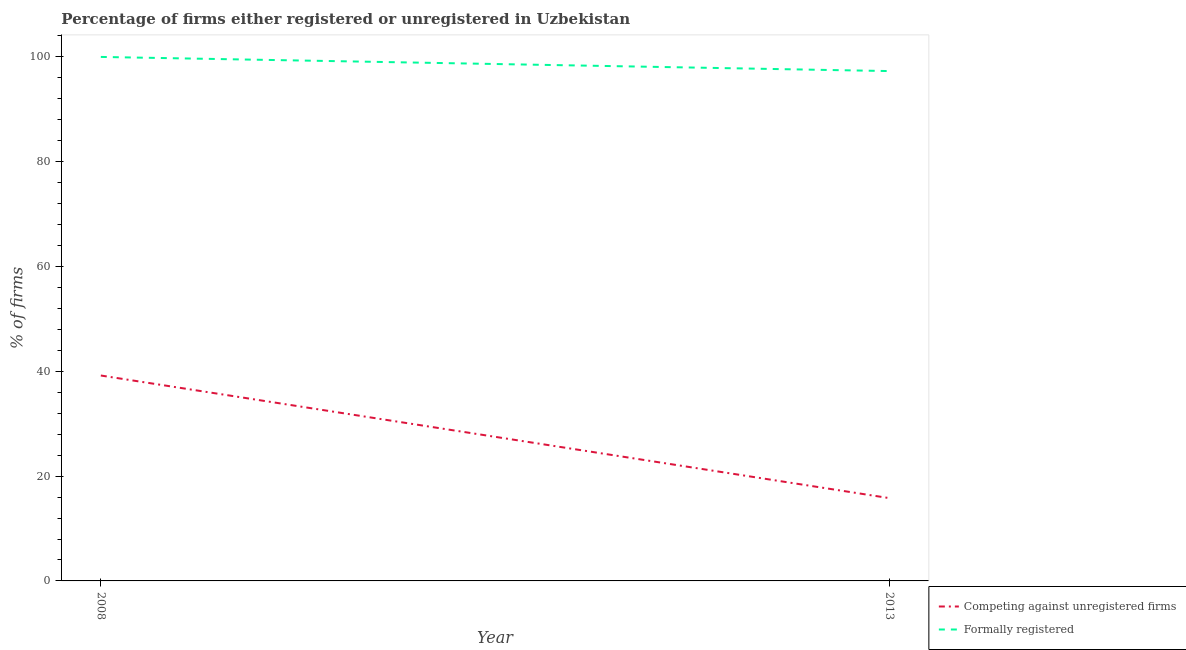How many different coloured lines are there?
Keep it short and to the point. 2. Across all years, what is the maximum percentage of formally registered firms?
Your answer should be compact. 100. Across all years, what is the minimum percentage of registered firms?
Offer a terse response. 15.8. In which year was the percentage of registered firms maximum?
Provide a short and direct response. 2008. In which year was the percentage of formally registered firms minimum?
Offer a very short reply. 2013. What is the total percentage of formally registered firms in the graph?
Your answer should be very brief. 197.3. What is the difference between the percentage of registered firms in 2008 and that in 2013?
Provide a short and direct response. 23.4. What is the difference between the percentage of registered firms in 2013 and the percentage of formally registered firms in 2008?
Keep it short and to the point. -84.2. In the year 2008, what is the difference between the percentage of registered firms and percentage of formally registered firms?
Your answer should be compact. -60.8. What is the ratio of the percentage of registered firms in 2008 to that in 2013?
Your answer should be very brief. 2.48. Is the percentage of registered firms in 2008 less than that in 2013?
Give a very brief answer. No. Is the percentage of formally registered firms strictly greater than the percentage of registered firms over the years?
Your answer should be very brief. Yes. Is the percentage of formally registered firms strictly less than the percentage of registered firms over the years?
Provide a short and direct response. No. How many lines are there?
Your answer should be compact. 2. What is the difference between two consecutive major ticks on the Y-axis?
Ensure brevity in your answer.  20. Are the values on the major ticks of Y-axis written in scientific E-notation?
Offer a very short reply. No. Where does the legend appear in the graph?
Ensure brevity in your answer.  Bottom right. How many legend labels are there?
Your response must be concise. 2. How are the legend labels stacked?
Your answer should be compact. Vertical. What is the title of the graph?
Your answer should be very brief. Percentage of firms either registered or unregistered in Uzbekistan. Does "Girls" appear as one of the legend labels in the graph?
Your answer should be very brief. No. What is the label or title of the X-axis?
Give a very brief answer. Year. What is the label or title of the Y-axis?
Your answer should be very brief. % of firms. What is the % of firms of Competing against unregistered firms in 2008?
Provide a short and direct response. 39.2. What is the % of firms of Competing against unregistered firms in 2013?
Your response must be concise. 15.8. What is the % of firms in Formally registered in 2013?
Ensure brevity in your answer.  97.3. Across all years, what is the maximum % of firms in Competing against unregistered firms?
Provide a short and direct response. 39.2. Across all years, what is the maximum % of firms of Formally registered?
Provide a short and direct response. 100. Across all years, what is the minimum % of firms in Competing against unregistered firms?
Offer a very short reply. 15.8. Across all years, what is the minimum % of firms of Formally registered?
Keep it short and to the point. 97.3. What is the total % of firms in Formally registered in the graph?
Your answer should be compact. 197.3. What is the difference between the % of firms in Competing against unregistered firms in 2008 and that in 2013?
Give a very brief answer. 23.4. What is the difference between the % of firms of Formally registered in 2008 and that in 2013?
Give a very brief answer. 2.7. What is the difference between the % of firms of Competing against unregistered firms in 2008 and the % of firms of Formally registered in 2013?
Your answer should be very brief. -58.1. What is the average % of firms in Formally registered per year?
Offer a terse response. 98.65. In the year 2008, what is the difference between the % of firms in Competing against unregistered firms and % of firms in Formally registered?
Make the answer very short. -60.8. In the year 2013, what is the difference between the % of firms in Competing against unregistered firms and % of firms in Formally registered?
Your answer should be very brief. -81.5. What is the ratio of the % of firms of Competing against unregistered firms in 2008 to that in 2013?
Offer a terse response. 2.48. What is the ratio of the % of firms in Formally registered in 2008 to that in 2013?
Ensure brevity in your answer.  1.03. What is the difference between the highest and the second highest % of firms of Competing against unregistered firms?
Ensure brevity in your answer.  23.4. What is the difference between the highest and the lowest % of firms of Competing against unregistered firms?
Give a very brief answer. 23.4. 